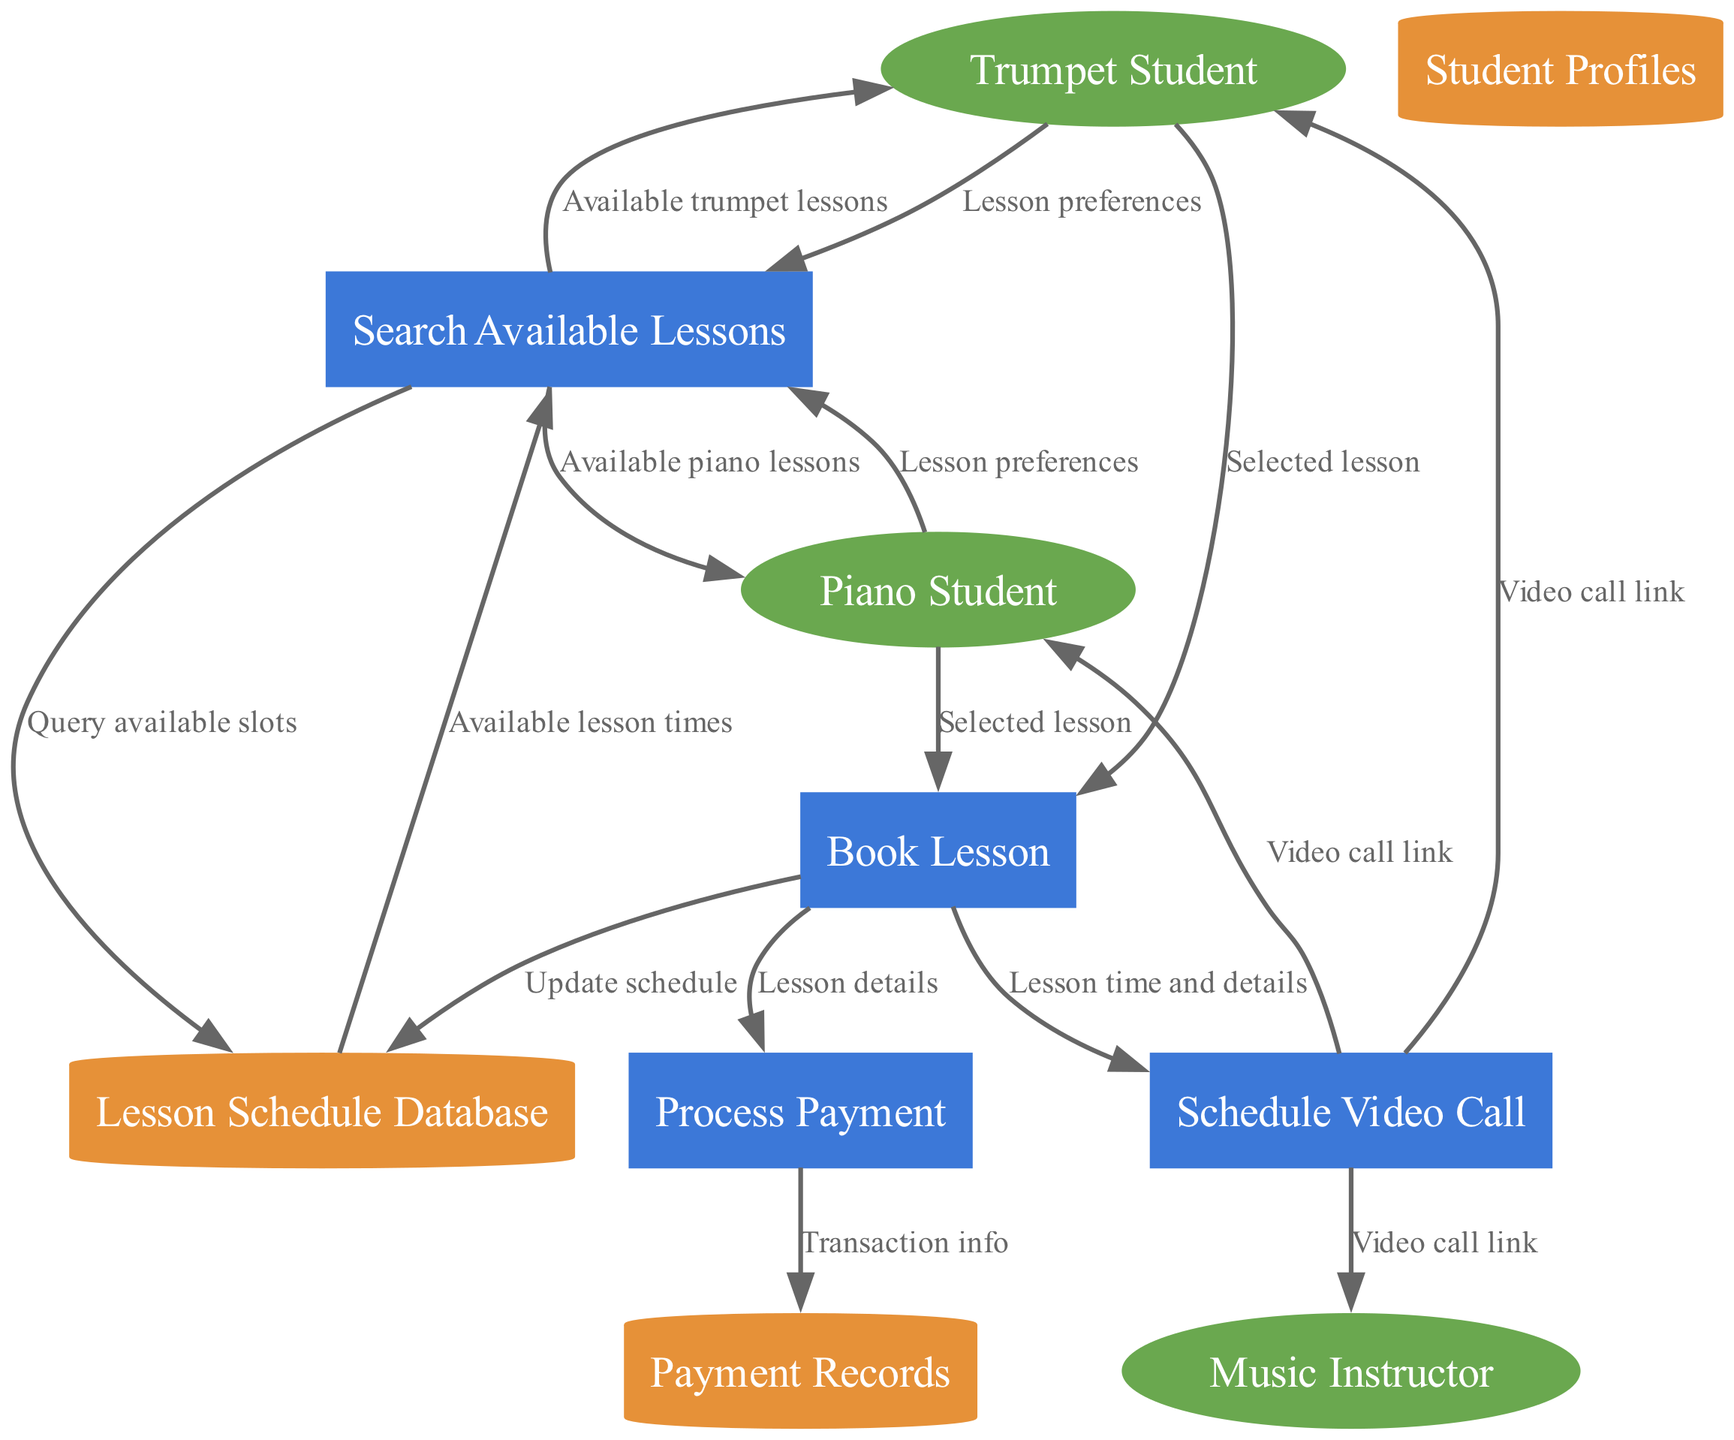What are the external entities in this diagram? The external entities listed in the diagram are "Trumpet Student," "Piano Student," and "Music Instructor." These are the inputs or actors that interact with the system.
Answer: Trumpet Student, Piano Student, Music Instructor How many processes are shown in the diagram? The diagram displays four processes: "Search Available Lessons," "Book Lesson," "Process Payment," and "Schedule Video Call." This refers to the computational tasks that the system performs.
Answer: Four What data store receives updates from the "Book Lesson" process? The "Lesson Schedule Database" receives updates when a lesson is booked, indicating that this data store holds information that gets modified during the booking process.
Answer: Lesson Schedule Database Which external entity receives the "Video call link" from the "Schedule Video Call" process? The "Video call link" is sent to three entities: "Music Instructor," "Trumpet Student," and "Piano Student." Since this asks about the external entity, it can refer to any of these three.
Answer: Music Instructor, Trumpet Student, Piano Student What flow is used to connect "Search Available Lessons" to "Lesson Schedule Database"? The connection is represented by the flow labeled "Query available slots," indicating that this is the information requested from the database.
Answer: Query available slots Which process follows the "Book Lesson" in the data flow? "Process Payment" follows "Book Lesson" as the next step in the data flow, indicating that payment processing occurs after booking a lesson.
Answer: Process Payment What information is sent from "Process Payment" to "Payment Records"? The flow labeled "Transaction info" is sent from "Process Payment" to "Payment Records," which likely captures the details of each payment transaction.
Answer: Transaction info How do "Trumpet Student" and "Piano Student" interact with "Search Available Lessons"? Both students provide their "Lesson preferences" to "Search Available Lessons," allowing them to find suitable lessons based on their specific criteria.
Answer: Lesson preferences What kind of link do the external entities receive from the "Schedule Video Call" process? The external entities receive a "Video call link," which is essential for connecting students and instructor to the virtual lesson.
Answer: Video call link 